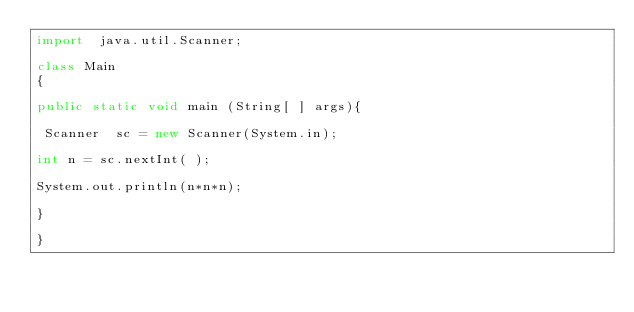<code> <loc_0><loc_0><loc_500><loc_500><_Java_>import  java.util.Scanner;
 
class Main
{

public static void main (String[ ] args){

 Scanner  sc = new Scanner(System.in);

int n = sc.nextInt( );

System.out.println(n*n*n);

}

}
</code> 